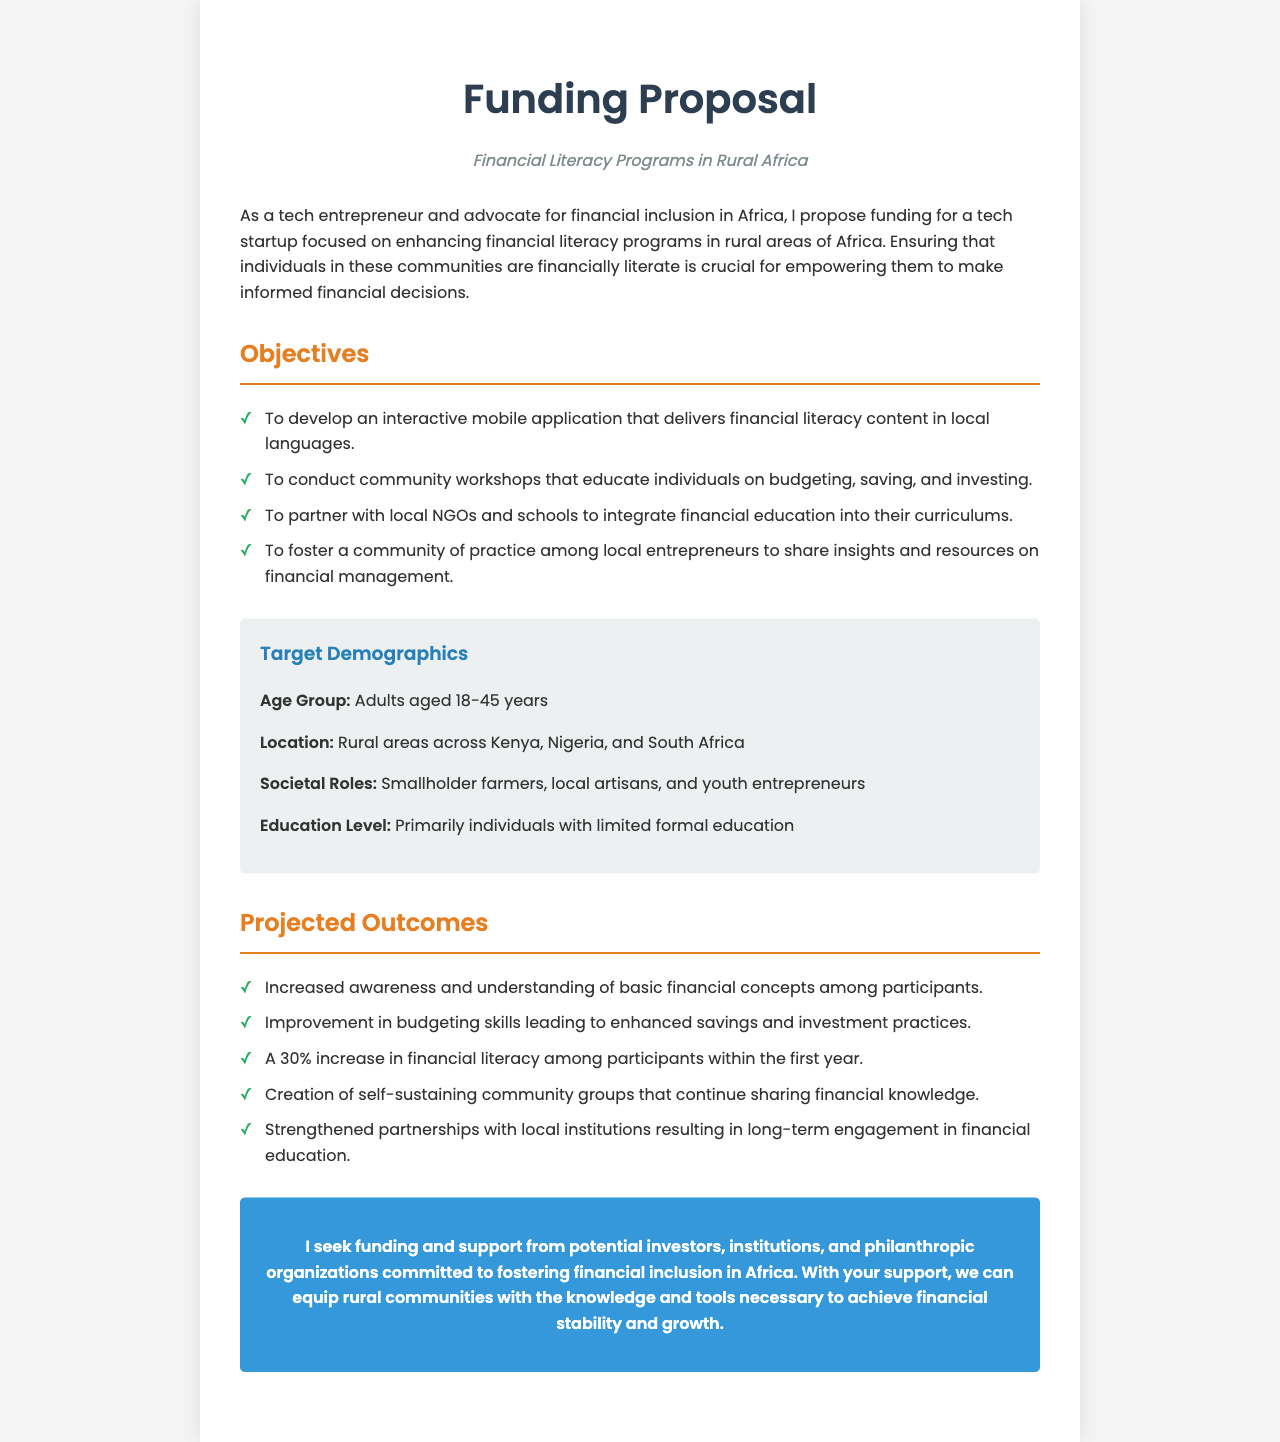what is the main focus of the funding proposal? The main focus of the funding proposal is to enhance financial literacy programs in rural areas of Africa.
Answer: financial literacy programs which countries are mentioned as target locations? The countries mentioned as target locations are Kenya, Nigeria, and South Africa.
Answer: Kenya, Nigeria, and South Africa what age group is targeted for the financial literacy programs? The targeted age group for the financial literacy programs is adults aged 18-45 years.
Answer: adults aged 18-45 years what is one of the objectives of the proposal? One of the objectives of the proposal is to develop an interactive mobile application that delivers financial literacy content in local languages.
Answer: develop an interactive mobile application how much increase in financial literacy is projected within the first year? The projected increase in financial literacy among participants within the first year is 30%.
Answer: 30% what type of community groups are intended to be created as an outcome? The intended community groups are self-sustaining community groups that continue sharing financial knowledge.
Answer: self-sustaining community groups which economic roles are included in the target demographics? The economic roles included in the target demographics are smallholder farmers, local artisans, and youth entrepreneurs.
Answer: smallholder farmers, local artisans, and youth entrepreneurs who is the intended audience for this funding proposal? The intended audience for the funding proposal includes potential investors, institutions, and philanthropic organizations.
Answer: potential investors, institutions, and philanthropic organizations what is a key outcome related to partnerships mentioned in the proposal? A key outcome related to partnerships is strengthened partnerships with local institutions resulting in long-term engagement in financial education.
Answer: strengthened partnerships with local institutions 